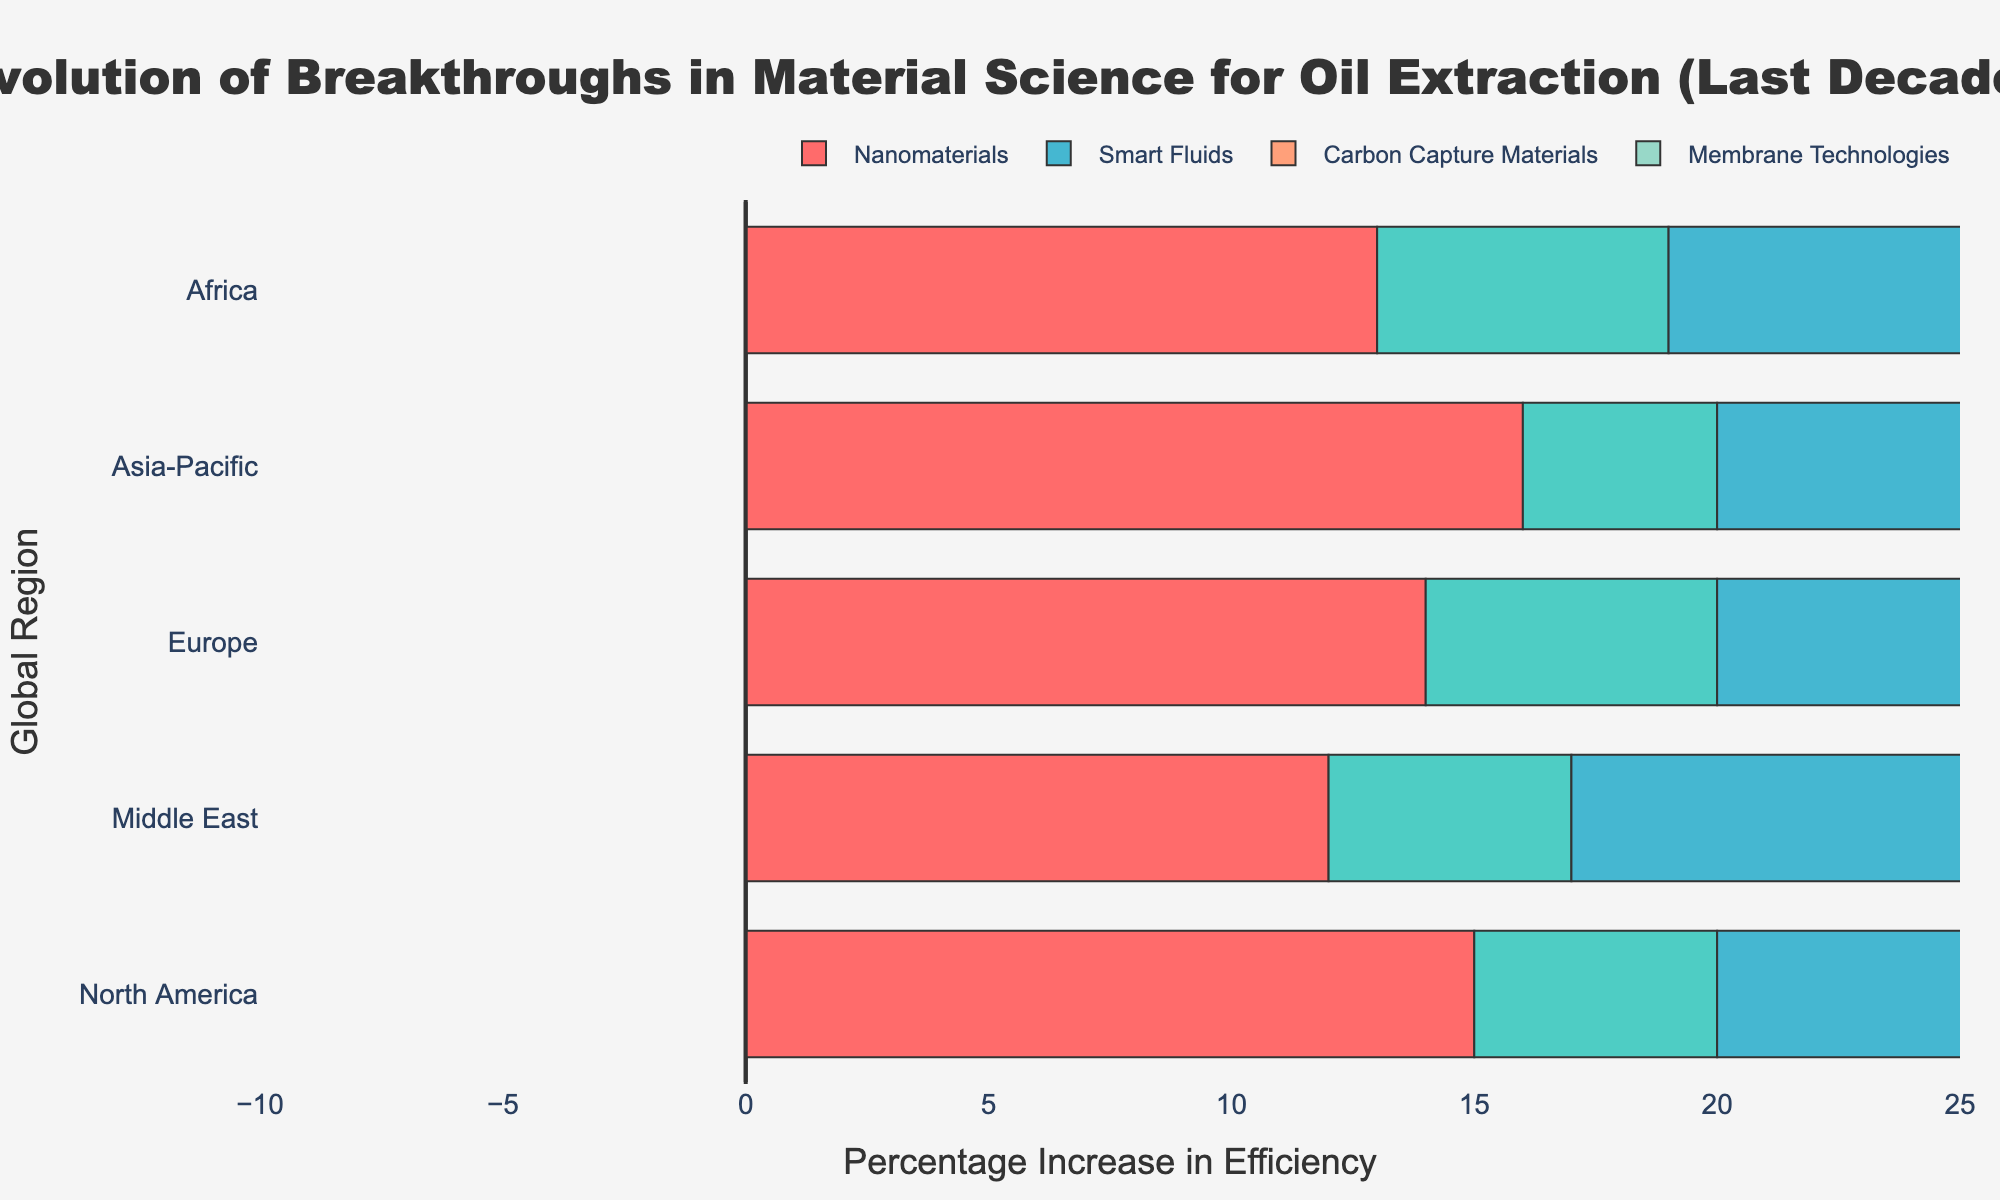Which region saw the highest positive impact from Carbon Capture Materials? To find the region with the highest positive impact from Carbon Capture Materials, look at the lengths of the bars depicting Carbon Capture Materials in each region. The bar for Europe in relation to Carbon Capture Materials appears longest.
Answer: Europe Which breakthrough category had the most positive impact across all regions combined? To determine the breakthrough category with the most positive impact, count the number of positive impacts across all regions for each category. Membrane Technologies consistently show long bars in the positive direction across all regions.
Answer: Membrane Technologies How did Smart Fluids impact oil extraction processes in North America compared to Europe? Look at the length and direction of the bars for Smart Fluids in North America and Europe. In North America, the bar is 12% positive, while in Europe, it is 10% positive.
Answer: North America had a greater positive impact (+12% vs +10%) Are there any regions where High-Temperature Alloys had a positive impact? Scan the bars for High-Temperature Alloys across all regions. Since all bars for High-Temperature Alloys extend in the negative direction, there are no regions with a positive impact.
Answer: No Compare the impact of Nanomaterials in the Middle East and Asia-Pacific. Examine the lengths of the bars for Nanomaterials in both regions. In the Middle East, the impact is 12% positive, while in the Asia-Pacific, it is 16% positive.
Answer: Asia-Pacific had a higher positive impact (16% vs 12%) Which category showed the smallest variation in impact across all regions? To identify the category with the smallest variation, mentally compare the length differences of the bars for each category across regions. Carbon Capture Materials appear to have consistently long and similar lengths across regions.
Answer: Carbon Capture Materials What is the average positive impact of Smart Fluids across all regions? First, identify the positive impacts of Smart Fluids in all regions: North America (12%), Europe (10%), Asia-Pacific (13%), Middle East (11%), Africa (9%). Sum these values (12 + 10 + 13 + 11 + 9 = 55) and divide by 5 (55 / 5).
Answer: 11% Which region had no positive impact from High-Temperature Alloys? Look at the bars representing High-Temperature Alloys across all regions. All regions show negative impacts, so this question implicitly seeks the verification of negative impact consistency.
Answer: All regions Which breakthrough had the largest reduction in costs in Africa? Identify the reduction in costs for each breakthrough in Africa. The breakthroughs and their cost impacts: Nanomaterials (10%), High-Temperature Alloys (7%), Smart Fluids (5%), Carbon Capture Materials (6%), Membrane Technologies (3%). Nanomaterials had the highest cost reduction.
Answer: Nanomaterials 